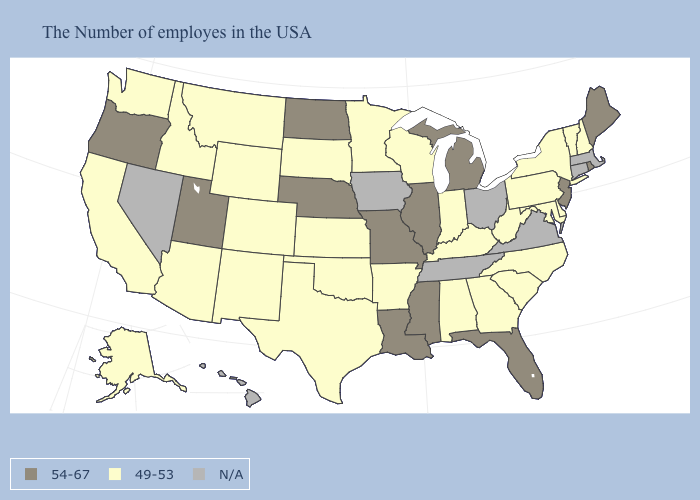Name the states that have a value in the range 49-53?
Write a very short answer. New Hampshire, Vermont, New York, Delaware, Maryland, Pennsylvania, North Carolina, South Carolina, West Virginia, Georgia, Kentucky, Indiana, Alabama, Wisconsin, Arkansas, Minnesota, Kansas, Oklahoma, Texas, South Dakota, Wyoming, Colorado, New Mexico, Montana, Arizona, Idaho, California, Washington, Alaska. Which states hav the highest value in the MidWest?
Write a very short answer. Michigan, Illinois, Missouri, Nebraska, North Dakota. Name the states that have a value in the range 54-67?
Give a very brief answer. Maine, Rhode Island, New Jersey, Florida, Michigan, Illinois, Mississippi, Louisiana, Missouri, Nebraska, North Dakota, Utah, Oregon. What is the value of Massachusetts?
Answer briefly. N/A. Which states have the lowest value in the USA?
Answer briefly. New Hampshire, Vermont, New York, Delaware, Maryland, Pennsylvania, North Carolina, South Carolina, West Virginia, Georgia, Kentucky, Indiana, Alabama, Wisconsin, Arkansas, Minnesota, Kansas, Oklahoma, Texas, South Dakota, Wyoming, Colorado, New Mexico, Montana, Arizona, Idaho, California, Washington, Alaska. How many symbols are there in the legend?
Give a very brief answer. 3. What is the highest value in the South ?
Short answer required. 54-67. Is the legend a continuous bar?
Quick response, please. No. What is the lowest value in the USA?
Short answer required. 49-53. What is the value of Indiana?
Answer briefly. 49-53. What is the value of California?
Concise answer only. 49-53. Name the states that have a value in the range 54-67?
Short answer required. Maine, Rhode Island, New Jersey, Florida, Michigan, Illinois, Mississippi, Louisiana, Missouri, Nebraska, North Dakota, Utah, Oregon. What is the value of Minnesota?
Give a very brief answer. 49-53. Does New York have the highest value in the Northeast?
Quick response, please. No. Among the states that border Oklahoma , which have the lowest value?
Give a very brief answer. Arkansas, Kansas, Texas, Colorado, New Mexico. 